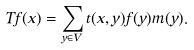Convert formula to latex. <formula><loc_0><loc_0><loc_500><loc_500>T { f } ( x ) = \sum _ { y \in V } t ( x , y ) { f } ( y ) m ( y ) .</formula> 